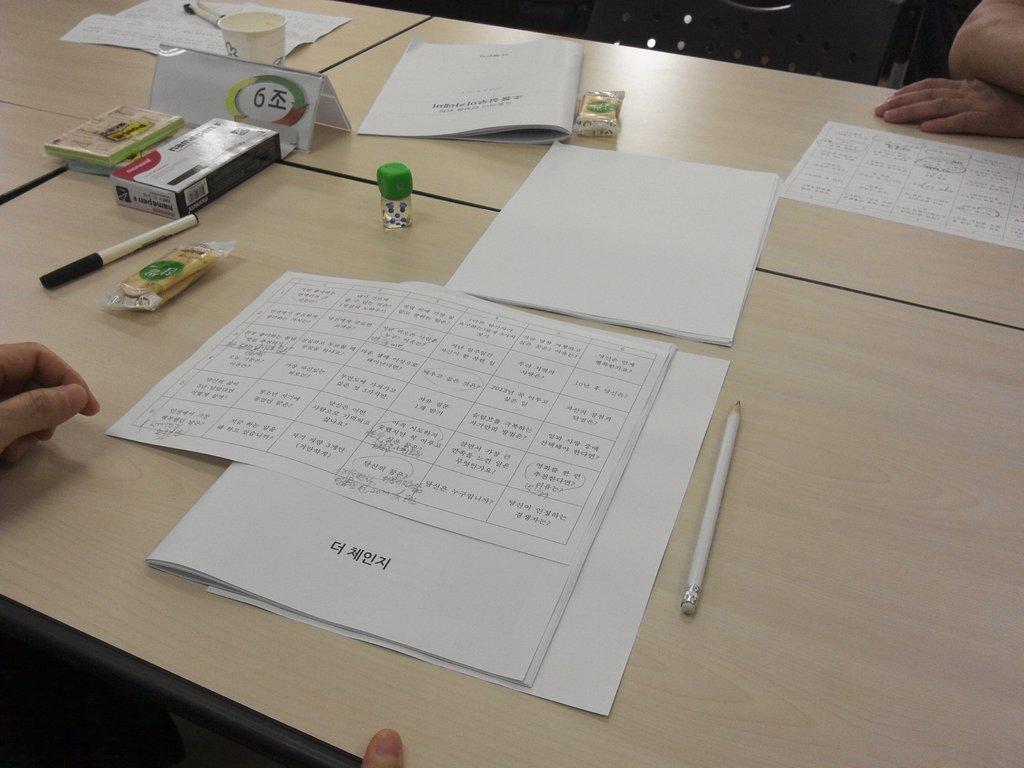Could you give a brief overview of what you see in this image? There is a table and on the table there are some papers,pens and other stationery items. 